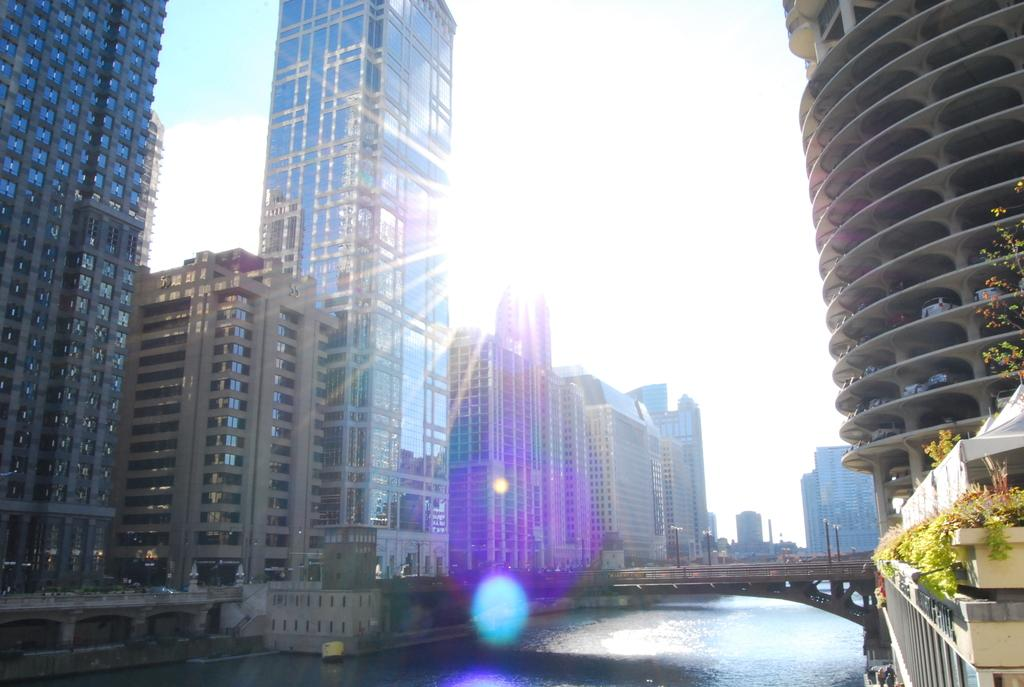What type of natural feature is present in the image? There is a lake in the image. What structures can be seen near the lake? There are buildings on both sides of the lake. What type of vegetation is visible in the image? There are plants visible in the image. What type of bells can be heard ringing in the image? There are no bells present in the image, and therefore no sound can be heard. 